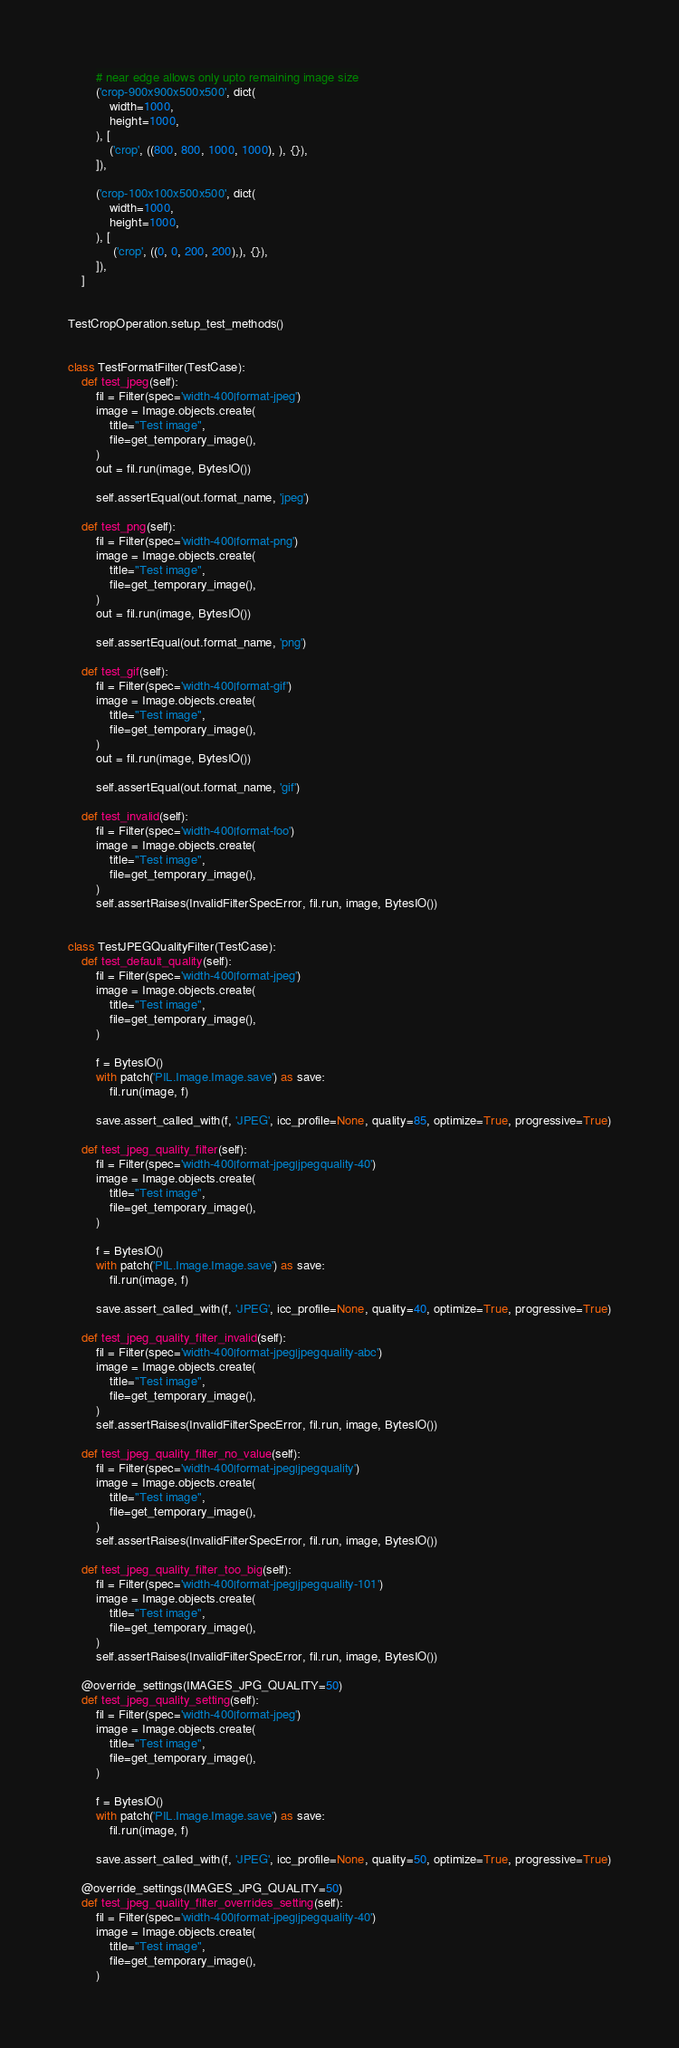<code> <loc_0><loc_0><loc_500><loc_500><_Python_>        # near edge allows only upto remaining image size
        ('crop-900x900x500x500', dict(
            width=1000,
            height=1000,
        ), [
            ('crop', ((800, 800, 1000, 1000), ), {}),
        ]),

        ('crop-100x100x500x500', dict(
            width=1000,
            height=1000,
        ), [
             ('crop', ((0, 0, 200, 200),), {}),
        ]),
    ]


TestCropOperation.setup_test_methods()


class TestFormatFilter(TestCase):
    def test_jpeg(self):
        fil = Filter(spec='width-400|format-jpeg')
        image = Image.objects.create(
            title="Test image",
            file=get_temporary_image(),
        )
        out = fil.run(image, BytesIO())

        self.assertEqual(out.format_name, 'jpeg')

    def test_png(self):
        fil = Filter(spec='width-400|format-png')
        image = Image.objects.create(
            title="Test image",
            file=get_temporary_image(),
        )
        out = fil.run(image, BytesIO())

        self.assertEqual(out.format_name, 'png')

    def test_gif(self):
        fil = Filter(spec='width-400|format-gif')
        image = Image.objects.create(
            title="Test image",
            file=get_temporary_image(),
        )
        out = fil.run(image, BytesIO())

        self.assertEqual(out.format_name, 'gif')

    def test_invalid(self):
        fil = Filter(spec='width-400|format-foo')
        image = Image.objects.create(
            title="Test image",
            file=get_temporary_image(),
        )
        self.assertRaises(InvalidFilterSpecError, fil.run, image, BytesIO())


class TestJPEGQualityFilter(TestCase):
    def test_default_quality(self):
        fil = Filter(spec='width-400|format-jpeg')
        image = Image.objects.create(
            title="Test image",
            file=get_temporary_image(),
        )

        f = BytesIO()
        with patch('PIL.Image.Image.save') as save:
            fil.run(image, f)

        save.assert_called_with(f, 'JPEG', icc_profile=None, quality=85, optimize=True, progressive=True)

    def test_jpeg_quality_filter(self):
        fil = Filter(spec='width-400|format-jpeg|jpegquality-40')
        image = Image.objects.create(
            title="Test image",
            file=get_temporary_image(),
        )

        f = BytesIO()
        with patch('PIL.Image.Image.save') as save:
            fil.run(image, f)

        save.assert_called_with(f, 'JPEG', icc_profile=None, quality=40, optimize=True, progressive=True)

    def test_jpeg_quality_filter_invalid(self):
        fil = Filter(spec='width-400|format-jpeg|jpegquality-abc')
        image = Image.objects.create(
            title="Test image",
            file=get_temporary_image(),
        )
        self.assertRaises(InvalidFilterSpecError, fil.run, image, BytesIO())

    def test_jpeg_quality_filter_no_value(self):
        fil = Filter(spec='width-400|format-jpeg|jpegquality')
        image = Image.objects.create(
            title="Test image",
            file=get_temporary_image(),
        )
        self.assertRaises(InvalidFilterSpecError, fil.run, image, BytesIO())

    def test_jpeg_quality_filter_too_big(self):
        fil = Filter(spec='width-400|format-jpeg|jpegquality-101')
        image = Image.objects.create(
            title="Test image",
            file=get_temporary_image(),
        )
        self.assertRaises(InvalidFilterSpecError, fil.run, image, BytesIO())

    @override_settings(IMAGES_JPG_QUALITY=50)
    def test_jpeg_quality_setting(self):
        fil = Filter(spec='width-400|format-jpeg')
        image = Image.objects.create(
            title="Test image",
            file=get_temporary_image(),
        )

        f = BytesIO()
        with patch('PIL.Image.Image.save') as save:
            fil.run(image, f)

        save.assert_called_with(f, 'JPEG', icc_profile=None, quality=50, optimize=True, progressive=True)

    @override_settings(IMAGES_JPG_QUALITY=50)
    def test_jpeg_quality_filter_overrides_setting(self):
        fil = Filter(spec='width-400|format-jpeg|jpegquality-40')
        image = Image.objects.create(
            title="Test image",
            file=get_temporary_image(),
        )
</code> 